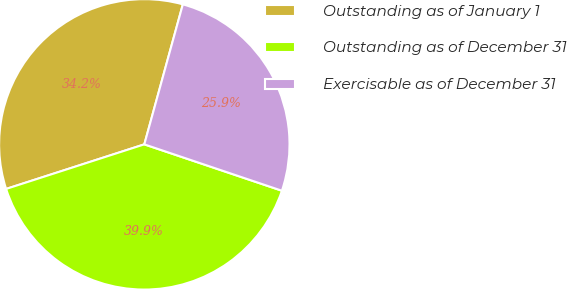Convert chart to OTSL. <chart><loc_0><loc_0><loc_500><loc_500><pie_chart><fcel>Outstanding as of January 1<fcel>Outstanding as of December 31<fcel>Exercisable as of December 31<nl><fcel>34.24%<fcel>39.86%<fcel>25.9%<nl></chart> 